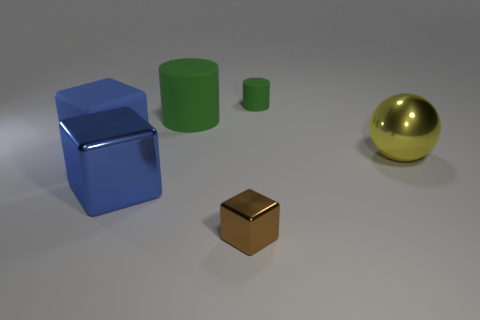There is a large thing that is the same color as the rubber cube; what material is it?
Offer a terse response. Metal. What number of metallic cubes are the same color as the large rubber cube?
Make the answer very short. 1. What is the shape of the metallic object that is in front of the large cube that is in front of the big yellow sphere?
Ensure brevity in your answer.  Cube. Is there a tiny red metallic object of the same shape as the big blue matte thing?
Your answer should be compact. No. There is a big metallic cube; is it the same color as the block that is behind the metallic sphere?
Offer a terse response. Yes. The rubber thing that is the same color as the large shiny block is what size?
Your answer should be very brief. Large. Are there any objects that have the same size as the blue metal cube?
Give a very brief answer. Yes. Does the big yellow thing have the same material as the cube right of the large blue metal block?
Provide a succinct answer. Yes. Is the number of small green objects greater than the number of shiny things?
Provide a succinct answer. No. What number of blocks are either large yellow metallic objects or tiny brown metal things?
Your response must be concise. 1. 